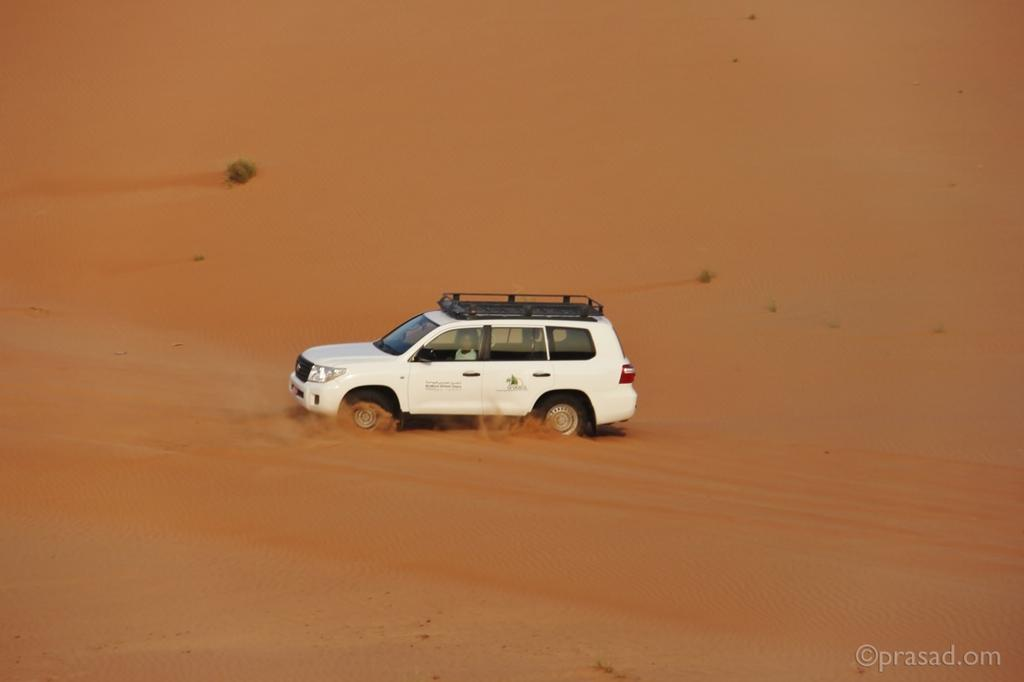What is the main subject of the image? There is a vehicle in the image. What is the terrain surrounding the vehicle? The vehicle is on sand. Is there anyone inside the vehicle? Yes, there is a person in the vehicle. Can you describe any additional features of the image? There is a watermark in the bottom right corner of the image. What type of holiday is the boy celebrating in the image? There is no boy or holiday present in the image; it features a vehicle on sand with a person inside. How does the person in the vehicle hear the music in the image? There is no music or indication of hearing in the image; it only shows a vehicle on sand with a person inside. 